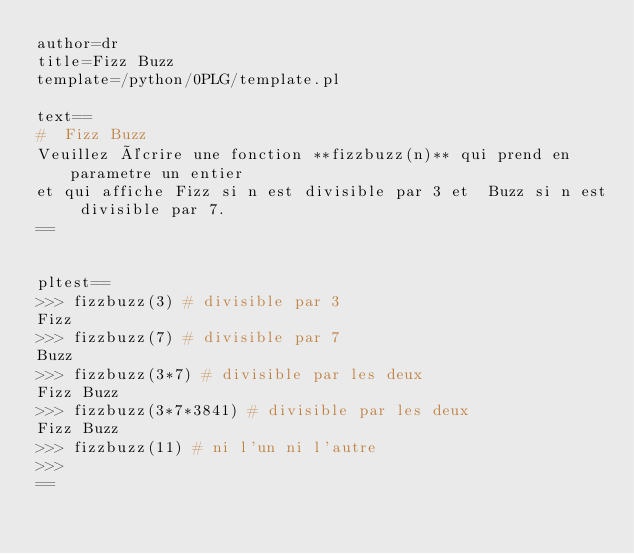Convert code to text. <code><loc_0><loc_0><loc_500><loc_500><_Perl_>author=dr
title=Fizz Buzz 
template=/python/0PLG/template.pl

text==
#  Fizz Buzz 
Veuillez écrire une fonction **fizzbuzz(n)** qui prend en parametre un entier
et qui affiche Fizz si n est divisible par 3 et  Buzz si n est divisible par 7.
==


pltest==
>>> fizzbuzz(3) # divisible par 3
Fizz
>>> fizzbuzz(7) # divisible par 7
Buzz
>>> fizzbuzz(3*7) # divisible par les deux 
Fizz Buzz
>>> fizzbuzz(3*7*3841) # divisible par les deux 
Fizz Buzz
>>> fizzbuzz(11) # ni l'un ni l'autre 
>>> 
==
</code> 